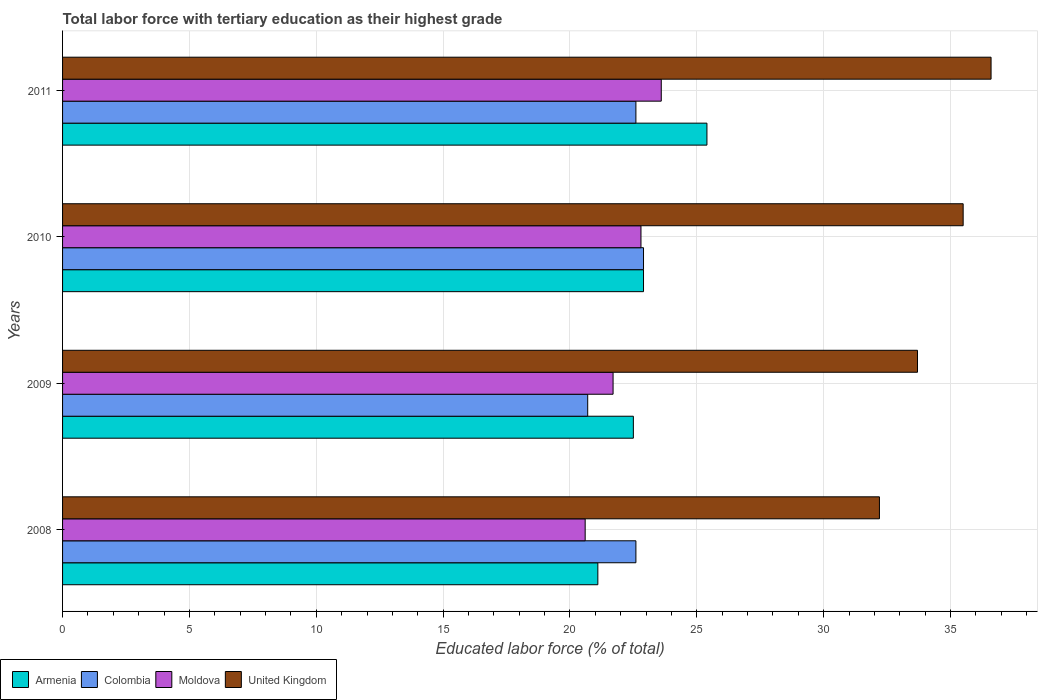How many different coloured bars are there?
Give a very brief answer. 4. How many bars are there on the 4th tick from the top?
Your answer should be very brief. 4. How many bars are there on the 1st tick from the bottom?
Offer a terse response. 4. What is the label of the 3rd group of bars from the top?
Offer a terse response. 2009. What is the percentage of male labor force with tertiary education in United Kingdom in 2008?
Offer a terse response. 32.2. Across all years, what is the maximum percentage of male labor force with tertiary education in Colombia?
Your answer should be very brief. 22.9. Across all years, what is the minimum percentage of male labor force with tertiary education in Armenia?
Offer a very short reply. 21.1. What is the total percentage of male labor force with tertiary education in Colombia in the graph?
Offer a very short reply. 88.8. What is the difference between the percentage of male labor force with tertiary education in United Kingdom in 2009 and that in 2010?
Your answer should be compact. -1.8. What is the difference between the percentage of male labor force with tertiary education in United Kingdom in 2010 and the percentage of male labor force with tertiary education in Moldova in 2011?
Give a very brief answer. 11.9. What is the average percentage of male labor force with tertiary education in Moldova per year?
Keep it short and to the point. 22.18. In the year 2010, what is the difference between the percentage of male labor force with tertiary education in Moldova and percentage of male labor force with tertiary education in Colombia?
Offer a terse response. -0.1. In how many years, is the percentage of male labor force with tertiary education in United Kingdom greater than 21 %?
Provide a succinct answer. 4. What is the ratio of the percentage of male labor force with tertiary education in United Kingdom in 2009 to that in 2011?
Your answer should be very brief. 0.92. Is the percentage of male labor force with tertiary education in United Kingdom in 2009 less than that in 2011?
Keep it short and to the point. Yes. Is the difference between the percentage of male labor force with tertiary education in Moldova in 2008 and 2011 greater than the difference between the percentage of male labor force with tertiary education in Colombia in 2008 and 2011?
Provide a short and direct response. No. What is the difference between the highest and the lowest percentage of male labor force with tertiary education in Moldova?
Your response must be concise. 3. Is it the case that in every year, the sum of the percentage of male labor force with tertiary education in Colombia and percentage of male labor force with tertiary education in United Kingdom is greater than the sum of percentage of male labor force with tertiary education in Armenia and percentage of male labor force with tertiary education in Moldova?
Offer a terse response. Yes. What does the 4th bar from the top in 2008 represents?
Your response must be concise. Armenia. What does the 3rd bar from the bottom in 2010 represents?
Give a very brief answer. Moldova. Is it the case that in every year, the sum of the percentage of male labor force with tertiary education in Moldova and percentage of male labor force with tertiary education in United Kingdom is greater than the percentage of male labor force with tertiary education in Colombia?
Make the answer very short. Yes. Are the values on the major ticks of X-axis written in scientific E-notation?
Provide a short and direct response. No. What is the title of the graph?
Offer a very short reply. Total labor force with tertiary education as their highest grade. Does "Turkey" appear as one of the legend labels in the graph?
Give a very brief answer. No. What is the label or title of the X-axis?
Ensure brevity in your answer.  Educated labor force (% of total). What is the Educated labor force (% of total) of Armenia in 2008?
Provide a short and direct response. 21.1. What is the Educated labor force (% of total) of Colombia in 2008?
Provide a short and direct response. 22.6. What is the Educated labor force (% of total) of Moldova in 2008?
Give a very brief answer. 20.6. What is the Educated labor force (% of total) of United Kingdom in 2008?
Give a very brief answer. 32.2. What is the Educated labor force (% of total) in Armenia in 2009?
Keep it short and to the point. 22.5. What is the Educated labor force (% of total) in Colombia in 2009?
Keep it short and to the point. 20.7. What is the Educated labor force (% of total) of Moldova in 2009?
Offer a terse response. 21.7. What is the Educated labor force (% of total) of United Kingdom in 2009?
Your answer should be compact. 33.7. What is the Educated labor force (% of total) in Armenia in 2010?
Make the answer very short. 22.9. What is the Educated labor force (% of total) of Colombia in 2010?
Offer a terse response. 22.9. What is the Educated labor force (% of total) of Moldova in 2010?
Keep it short and to the point. 22.8. What is the Educated labor force (% of total) in United Kingdom in 2010?
Ensure brevity in your answer.  35.5. What is the Educated labor force (% of total) of Armenia in 2011?
Your answer should be compact. 25.4. What is the Educated labor force (% of total) of Colombia in 2011?
Give a very brief answer. 22.6. What is the Educated labor force (% of total) of Moldova in 2011?
Your response must be concise. 23.6. What is the Educated labor force (% of total) in United Kingdom in 2011?
Your answer should be very brief. 36.6. Across all years, what is the maximum Educated labor force (% of total) of Armenia?
Offer a very short reply. 25.4. Across all years, what is the maximum Educated labor force (% of total) of Colombia?
Provide a succinct answer. 22.9. Across all years, what is the maximum Educated labor force (% of total) of Moldova?
Provide a succinct answer. 23.6. Across all years, what is the maximum Educated labor force (% of total) in United Kingdom?
Offer a terse response. 36.6. Across all years, what is the minimum Educated labor force (% of total) in Armenia?
Provide a succinct answer. 21.1. Across all years, what is the minimum Educated labor force (% of total) of Colombia?
Provide a succinct answer. 20.7. Across all years, what is the minimum Educated labor force (% of total) in Moldova?
Make the answer very short. 20.6. Across all years, what is the minimum Educated labor force (% of total) in United Kingdom?
Your answer should be compact. 32.2. What is the total Educated labor force (% of total) in Armenia in the graph?
Your response must be concise. 91.9. What is the total Educated labor force (% of total) of Colombia in the graph?
Keep it short and to the point. 88.8. What is the total Educated labor force (% of total) of Moldova in the graph?
Ensure brevity in your answer.  88.7. What is the total Educated labor force (% of total) in United Kingdom in the graph?
Give a very brief answer. 138. What is the difference between the Educated labor force (% of total) of Armenia in 2008 and that in 2009?
Provide a short and direct response. -1.4. What is the difference between the Educated labor force (% of total) in Colombia in 2008 and that in 2009?
Your answer should be very brief. 1.9. What is the difference between the Educated labor force (% of total) in Moldova in 2008 and that in 2009?
Provide a short and direct response. -1.1. What is the difference between the Educated labor force (% of total) in United Kingdom in 2008 and that in 2009?
Your answer should be very brief. -1.5. What is the difference between the Educated labor force (% of total) of Moldova in 2008 and that in 2010?
Ensure brevity in your answer.  -2.2. What is the difference between the Educated labor force (% of total) of United Kingdom in 2008 and that in 2010?
Offer a terse response. -3.3. What is the difference between the Educated labor force (% of total) of Colombia in 2008 and that in 2011?
Provide a short and direct response. 0. What is the difference between the Educated labor force (% of total) of United Kingdom in 2008 and that in 2011?
Give a very brief answer. -4.4. What is the difference between the Educated labor force (% of total) of Armenia in 2009 and that in 2010?
Keep it short and to the point. -0.4. What is the difference between the Educated labor force (% of total) of Armenia in 2009 and that in 2011?
Ensure brevity in your answer.  -2.9. What is the difference between the Educated labor force (% of total) in Colombia in 2009 and that in 2011?
Keep it short and to the point. -1.9. What is the difference between the Educated labor force (% of total) of Armenia in 2008 and the Educated labor force (% of total) of Colombia in 2009?
Your answer should be very brief. 0.4. What is the difference between the Educated labor force (% of total) of Armenia in 2008 and the Educated labor force (% of total) of Moldova in 2009?
Your answer should be very brief. -0.6. What is the difference between the Educated labor force (% of total) in Armenia in 2008 and the Educated labor force (% of total) in United Kingdom in 2009?
Offer a terse response. -12.6. What is the difference between the Educated labor force (% of total) in Colombia in 2008 and the Educated labor force (% of total) in United Kingdom in 2009?
Your answer should be very brief. -11.1. What is the difference between the Educated labor force (% of total) in Armenia in 2008 and the Educated labor force (% of total) in Moldova in 2010?
Keep it short and to the point. -1.7. What is the difference between the Educated labor force (% of total) of Armenia in 2008 and the Educated labor force (% of total) of United Kingdom in 2010?
Provide a short and direct response. -14.4. What is the difference between the Educated labor force (% of total) of Colombia in 2008 and the Educated labor force (% of total) of Moldova in 2010?
Make the answer very short. -0.2. What is the difference between the Educated labor force (% of total) in Colombia in 2008 and the Educated labor force (% of total) in United Kingdom in 2010?
Offer a very short reply. -12.9. What is the difference between the Educated labor force (% of total) of Moldova in 2008 and the Educated labor force (% of total) of United Kingdom in 2010?
Make the answer very short. -14.9. What is the difference between the Educated labor force (% of total) in Armenia in 2008 and the Educated labor force (% of total) in Colombia in 2011?
Ensure brevity in your answer.  -1.5. What is the difference between the Educated labor force (% of total) of Armenia in 2008 and the Educated labor force (% of total) of Moldova in 2011?
Your response must be concise. -2.5. What is the difference between the Educated labor force (% of total) in Armenia in 2008 and the Educated labor force (% of total) in United Kingdom in 2011?
Provide a succinct answer. -15.5. What is the difference between the Educated labor force (% of total) of Colombia in 2008 and the Educated labor force (% of total) of Moldova in 2011?
Ensure brevity in your answer.  -1. What is the difference between the Educated labor force (% of total) in Armenia in 2009 and the Educated labor force (% of total) in United Kingdom in 2010?
Make the answer very short. -13. What is the difference between the Educated labor force (% of total) of Colombia in 2009 and the Educated labor force (% of total) of United Kingdom in 2010?
Your answer should be very brief. -14.8. What is the difference between the Educated labor force (% of total) in Armenia in 2009 and the Educated labor force (% of total) in Moldova in 2011?
Offer a terse response. -1.1. What is the difference between the Educated labor force (% of total) of Armenia in 2009 and the Educated labor force (% of total) of United Kingdom in 2011?
Provide a succinct answer. -14.1. What is the difference between the Educated labor force (% of total) in Colombia in 2009 and the Educated labor force (% of total) in United Kingdom in 2011?
Your answer should be compact. -15.9. What is the difference between the Educated labor force (% of total) in Moldova in 2009 and the Educated labor force (% of total) in United Kingdom in 2011?
Give a very brief answer. -14.9. What is the difference between the Educated labor force (% of total) of Armenia in 2010 and the Educated labor force (% of total) of Moldova in 2011?
Your answer should be very brief. -0.7. What is the difference between the Educated labor force (% of total) in Armenia in 2010 and the Educated labor force (% of total) in United Kingdom in 2011?
Your response must be concise. -13.7. What is the difference between the Educated labor force (% of total) in Colombia in 2010 and the Educated labor force (% of total) in United Kingdom in 2011?
Ensure brevity in your answer.  -13.7. What is the average Educated labor force (% of total) of Armenia per year?
Provide a succinct answer. 22.98. What is the average Educated labor force (% of total) in Moldova per year?
Your response must be concise. 22.18. What is the average Educated labor force (% of total) in United Kingdom per year?
Your response must be concise. 34.5. In the year 2008, what is the difference between the Educated labor force (% of total) in Armenia and Educated labor force (% of total) in United Kingdom?
Give a very brief answer. -11.1. In the year 2008, what is the difference between the Educated labor force (% of total) of Colombia and Educated labor force (% of total) of United Kingdom?
Provide a succinct answer. -9.6. In the year 2008, what is the difference between the Educated labor force (% of total) in Moldova and Educated labor force (% of total) in United Kingdom?
Your answer should be very brief. -11.6. In the year 2009, what is the difference between the Educated labor force (% of total) in Armenia and Educated labor force (% of total) in Colombia?
Provide a short and direct response. 1.8. In the year 2009, what is the difference between the Educated labor force (% of total) in Armenia and Educated labor force (% of total) in United Kingdom?
Your answer should be compact. -11.2. In the year 2009, what is the difference between the Educated labor force (% of total) of Colombia and Educated labor force (% of total) of United Kingdom?
Offer a terse response. -13. In the year 2009, what is the difference between the Educated labor force (% of total) in Moldova and Educated labor force (% of total) in United Kingdom?
Make the answer very short. -12. In the year 2010, what is the difference between the Educated labor force (% of total) of Armenia and Educated labor force (% of total) of Colombia?
Offer a terse response. 0. In the year 2010, what is the difference between the Educated labor force (% of total) in Armenia and Educated labor force (% of total) in United Kingdom?
Offer a very short reply. -12.6. In the year 2010, what is the difference between the Educated labor force (% of total) in Colombia and Educated labor force (% of total) in Moldova?
Provide a succinct answer. 0.1. In the year 2011, what is the difference between the Educated labor force (% of total) of Armenia and Educated labor force (% of total) of Moldova?
Make the answer very short. 1.8. In the year 2011, what is the difference between the Educated labor force (% of total) of Colombia and Educated labor force (% of total) of United Kingdom?
Offer a terse response. -14. What is the ratio of the Educated labor force (% of total) in Armenia in 2008 to that in 2009?
Keep it short and to the point. 0.94. What is the ratio of the Educated labor force (% of total) of Colombia in 2008 to that in 2009?
Your answer should be compact. 1.09. What is the ratio of the Educated labor force (% of total) in Moldova in 2008 to that in 2009?
Ensure brevity in your answer.  0.95. What is the ratio of the Educated labor force (% of total) of United Kingdom in 2008 to that in 2009?
Offer a very short reply. 0.96. What is the ratio of the Educated labor force (% of total) of Armenia in 2008 to that in 2010?
Offer a terse response. 0.92. What is the ratio of the Educated labor force (% of total) of Colombia in 2008 to that in 2010?
Give a very brief answer. 0.99. What is the ratio of the Educated labor force (% of total) in Moldova in 2008 to that in 2010?
Ensure brevity in your answer.  0.9. What is the ratio of the Educated labor force (% of total) in United Kingdom in 2008 to that in 2010?
Keep it short and to the point. 0.91. What is the ratio of the Educated labor force (% of total) of Armenia in 2008 to that in 2011?
Your answer should be very brief. 0.83. What is the ratio of the Educated labor force (% of total) in Moldova in 2008 to that in 2011?
Keep it short and to the point. 0.87. What is the ratio of the Educated labor force (% of total) in United Kingdom in 2008 to that in 2011?
Make the answer very short. 0.88. What is the ratio of the Educated labor force (% of total) of Armenia in 2009 to that in 2010?
Give a very brief answer. 0.98. What is the ratio of the Educated labor force (% of total) of Colombia in 2009 to that in 2010?
Your response must be concise. 0.9. What is the ratio of the Educated labor force (% of total) of Moldova in 2009 to that in 2010?
Offer a terse response. 0.95. What is the ratio of the Educated labor force (% of total) in United Kingdom in 2009 to that in 2010?
Your answer should be very brief. 0.95. What is the ratio of the Educated labor force (% of total) of Armenia in 2009 to that in 2011?
Your answer should be compact. 0.89. What is the ratio of the Educated labor force (% of total) of Colombia in 2009 to that in 2011?
Provide a succinct answer. 0.92. What is the ratio of the Educated labor force (% of total) of Moldova in 2009 to that in 2011?
Give a very brief answer. 0.92. What is the ratio of the Educated labor force (% of total) in United Kingdom in 2009 to that in 2011?
Offer a terse response. 0.92. What is the ratio of the Educated labor force (% of total) in Armenia in 2010 to that in 2011?
Provide a short and direct response. 0.9. What is the ratio of the Educated labor force (% of total) of Colombia in 2010 to that in 2011?
Your answer should be very brief. 1.01. What is the ratio of the Educated labor force (% of total) in Moldova in 2010 to that in 2011?
Provide a short and direct response. 0.97. What is the ratio of the Educated labor force (% of total) in United Kingdom in 2010 to that in 2011?
Provide a succinct answer. 0.97. What is the difference between the highest and the second highest Educated labor force (% of total) of Colombia?
Provide a short and direct response. 0.3. What is the difference between the highest and the second highest Educated labor force (% of total) in United Kingdom?
Your response must be concise. 1.1. 